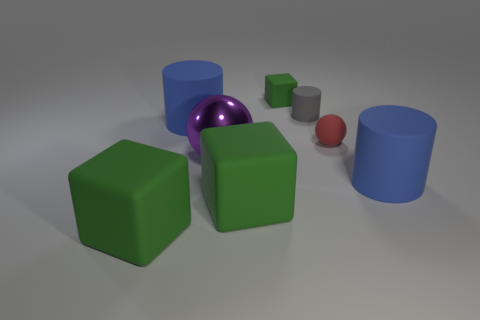Add 1 tiny cyan shiny balls. How many objects exist? 9 Subtract all cubes. How many objects are left? 5 Subtract all big yellow metal objects. Subtract all large purple things. How many objects are left? 7 Add 4 small gray rubber objects. How many small gray rubber objects are left? 5 Add 1 big rubber cubes. How many big rubber cubes exist? 3 Subtract 1 gray cylinders. How many objects are left? 7 